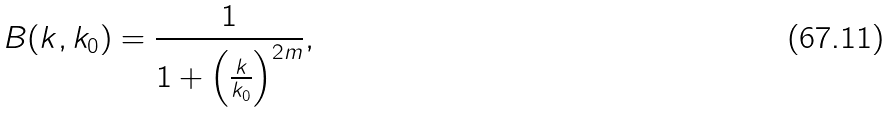Convert formula to latex. <formula><loc_0><loc_0><loc_500><loc_500>B ( k , k _ { 0 } ) = \frac { 1 } { 1 + \left ( \frac { k } { k _ { 0 } } \right ) ^ { 2 m } } ,</formula> 